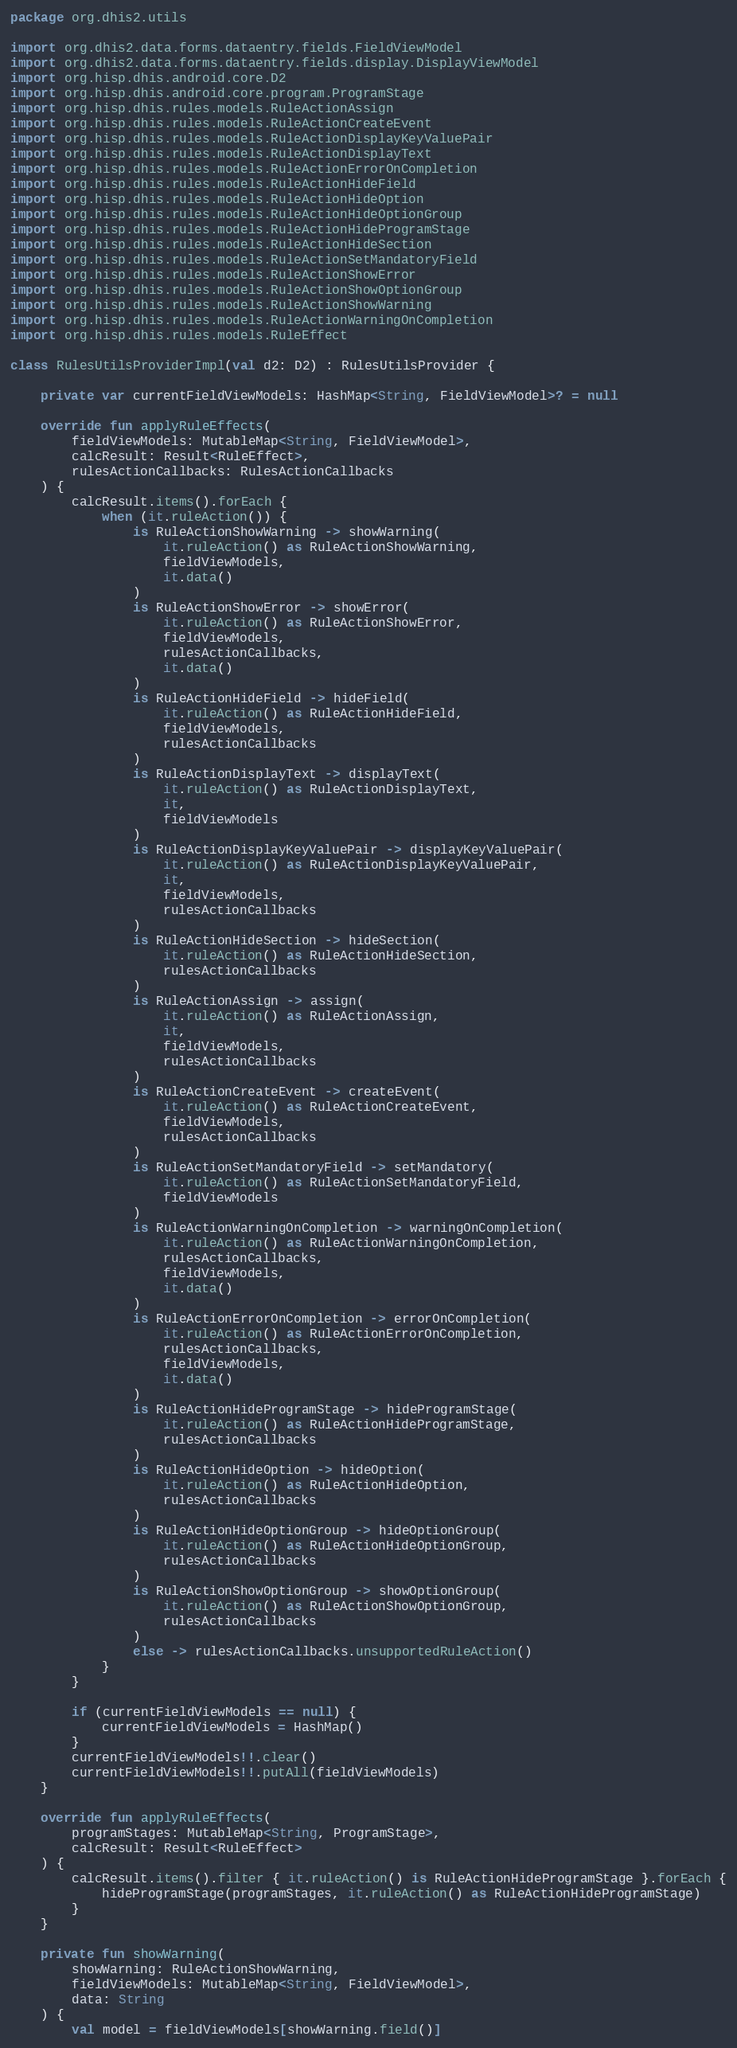Convert code to text. <code><loc_0><loc_0><loc_500><loc_500><_Kotlin_>package org.dhis2.utils

import org.dhis2.data.forms.dataentry.fields.FieldViewModel
import org.dhis2.data.forms.dataentry.fields.display.DisplayViewModel
import org.hisp.dhis.android.core.D2
import org.hisp.dhis.android.core.program.ProgramStage
import org.hisp.dhis.rules.models.RuleActionAssign
import org.hisp.dhis.rules.models.RuleActionCreateEvent
import org.hisp.dhis.rules.models.RuleActionDisplayKeyValuePair
import org.hisp.dhis.rules.models.RuleActionDisplayText
import org.hisp.dhis.rules.models.RuleActionErrorOnCompletion
import org.hisp.dhis.rules.models.RuleActionHideField
import org.hisp.dhis.rules.models.RuleActionHideOption
import org.hisp.dhis.rules.models.RuleActionHideOptionGroup
import org.hisp.dhis.rules.models.RuleActionHideProgramStage
import org.hisp.dhis.rules.models.RuleActionHideSection
import org.hisp.dhis.rules.models.RuleActionSetMandatoryField
import org.hisp.dhis.rules.models.RuleActionShowError
import org.hisp.dhis.rules.models.RuleActionShowOptionGroup
import org.hisp.dhis.rules.models.RuleActionShowWarning
import org.hisp.dhis.rules.models.RuleActionWarningOnCompletion
import org.hisp.dhis.rules.models.RuleEffect

class RulesUtilsProviderImpl(val d2: D2) : RulesUtilsProvider {

    private var currentFieldViewModels: HashMap<String, FieldViewModel>? = null

    override fun applyRuleEffects(
        fieldViewModels: MutableMap<String, FieldViewModel>,
        calcResult: Result<RuleEffect>,
        rulesActionCallbacks: RulesActionCallbacks
    ) {
        calcResult.items().forEach {
            when (it.ruleAction()) {
                is RuleActionShowWarning -> showWarning(
                    it.ruleAction() as RuleActionShowWarning,
                    fieldViewModels,
                    it.data()
                )
                is RuleActionShowError -> showError(
                    it.ruleAction() as RuleActionShowError,
                    fieldViewModels,
                    rulesActionCallbacks,
                    it.data()
                )
                is RuleActionHideField -> hideField(
                    it.ruleAction() as RuleActionHideField,
                    fieldViewModels,
                    rulesActionCallbacks
                )
                is RuleActionDisplayText -> displayText(
                    it.ruleAction() as RuleActionDisplayText,
                    it,
                    fieldViewModels
                )
                is RuleActionDisplayKeyValuePair -> displayKeyValuePair(
                    it.ruleAction() as RuleActionDisplayKeyValuePair,
                    it,
                    fieldViewModels,
                    rulesActionCallbacks
                )
                is RuleActionHideSection -> hideSection(
                    it.ruleAction() as RuleActionHideSection,
                    rulesActionCallbacks
                )
                is RuleActionAssign -> assign(
                    it.ruleAction() as RuleActionAssign,
                    it,
                    fieldViewModels,
                    rulesActionCallbacks
                )
                is RuleActionCreateEvent -> createEvent(
                    it.ruleAction() as RuleActionCreateEvent,
                    fieldViewModels,
                    rulesActionCallbacks
                )
                is RuleActionSetMandatoryField -> setMandatory(
                    it.ruleAction() as RuleActionSetMandatoryField,
                    fieldViewModels
                )
                is RuleActionWarningOnCompletion -> warningOnCompletion(
                    it.ruleAction() as RuleActionWarningOnCompletion,
                    rulesActionCallbacks,
                    fieldViewModels,
                    it.data()
                )
                is RuleActionErrorOnCompletion -> errorOnCompletion(
                    it.ruleAction() as RuleActionErrorOnCompletion,
                    rulesActionCallbacks,
                    fieldViewModels,
                    it.data()
                )
                is RuleActionHideProgramStage -> hideProgramStage(
                    it.ruleAction() as RuleActionHideProgramStage,
                    rulesActionCallbacks
                )
                is RuleActionHideOption -> hideOption(
                    it.ruleAction() as RuleActionHideOption,
                    rulesActionCallbacks
                )
                is RuleActionHideOptionGroup -> hideOptionGroup(
                    it.ruleAction() as RuleActionHideOptionGroup,
                    rulesActionCallbacks
                )
                is RuleActionShowOptionGroup -> showOptionGroup(
                    it.ruleAction() as RuleActionShowOptionGroup,
                    rulesActionCallbacks
                )
                else -> rulesActionCallbacks.unsupportedRuleAction()
            }
        }

        if (currentFieldViewModels == null) {
            currentFieldViewModels = HashMap()
        }
        currentFieldViewModels!!.clear()
        currentFieldViewModels!!.putAll(fieldViewModels)
    }

    override fun applyRuleEffects(
        programStages: MutableMap<String, ProgramStage>,
        calcResult: Result<RuleEffect>
    ) {
        calcResult.items().filter { it.ruleAction() is RuleActionHideProgramStage }.forEach {
            hideProgramStage(programStages, it.ruleAction() as RuleActionHideProgramStage)
        }
    }

    private fun showWarning(
        showWarning: RuleActionShowWarning,
        fieldViewModels: MutableMap<String, FieldViewModel>,
        data: String
    ) {
        val model = fieldViewModels[showWarning.field()]</code> 